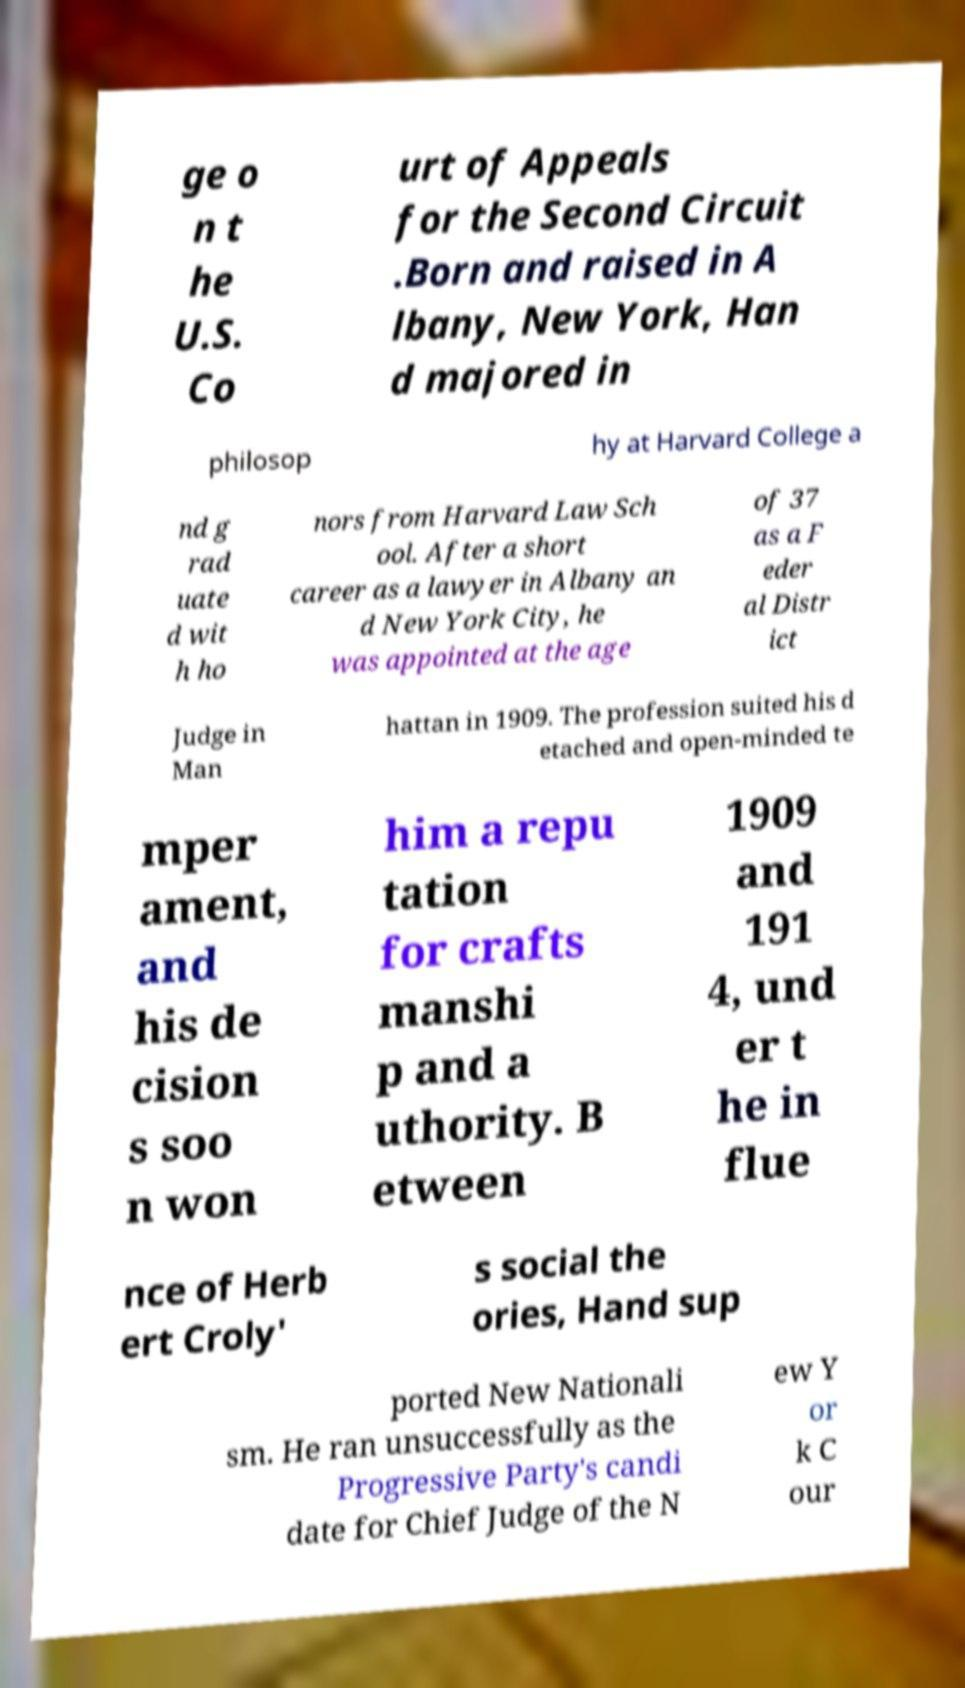There's text embedded in this image that I need extracted. Can you transcribe it verbatim? ge o n t he U.S. Co urt of Appeals for the Second Circuit .Born and raised in A lbany, New York, Han d majored in philosop hy at Harvard College a nd g rad uate d wit h ho nors from Harvard Law Sch ool. After a short career as a lawyer in Albany an d New York City, he was appointed at the age of 37 as a F eder al Distr ict Judge in Man hattan in 1909. The profession suited his d etached and open-minded te mper ament, and his de cision s soo n won him a repu tation for crafts manshi p and a uthority. B etween 1909 and 191 4, und er t he in flue nce of Herb ert Croly' s social the ories, Hand sup ported New Nationali sm. He ran unsuccessfully as the Progressive Party's candi date for Chief Judge of the N ew Y or k C our 